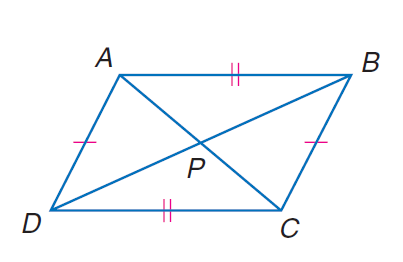Question: In quadrilateral A B C D, A C = 188, B D = 214, m \angle B P C = 70, and P is the midpoint of A C and B D. Find the perimeter of quadrilateral A B C D.
Choices:
A. 343.1
B. 423.1
C. 561.2
D. 671.2
Answer with the letter. Answer: C 